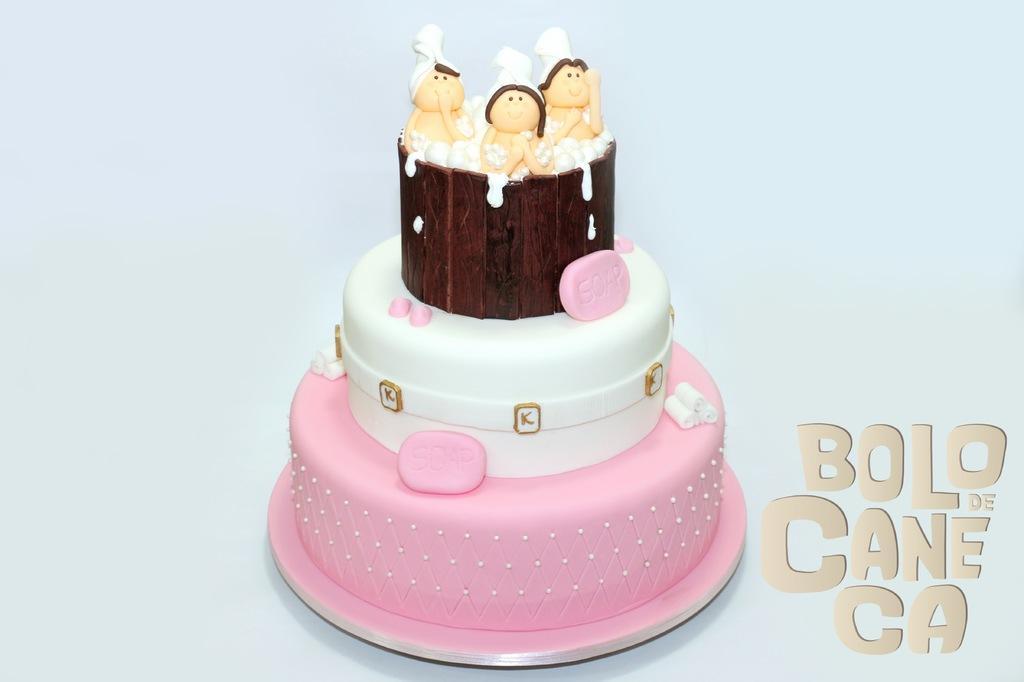Please provide a concise description of this image. In this image I can see the cake which is in white and pink color. And there are some toys on the cake. 